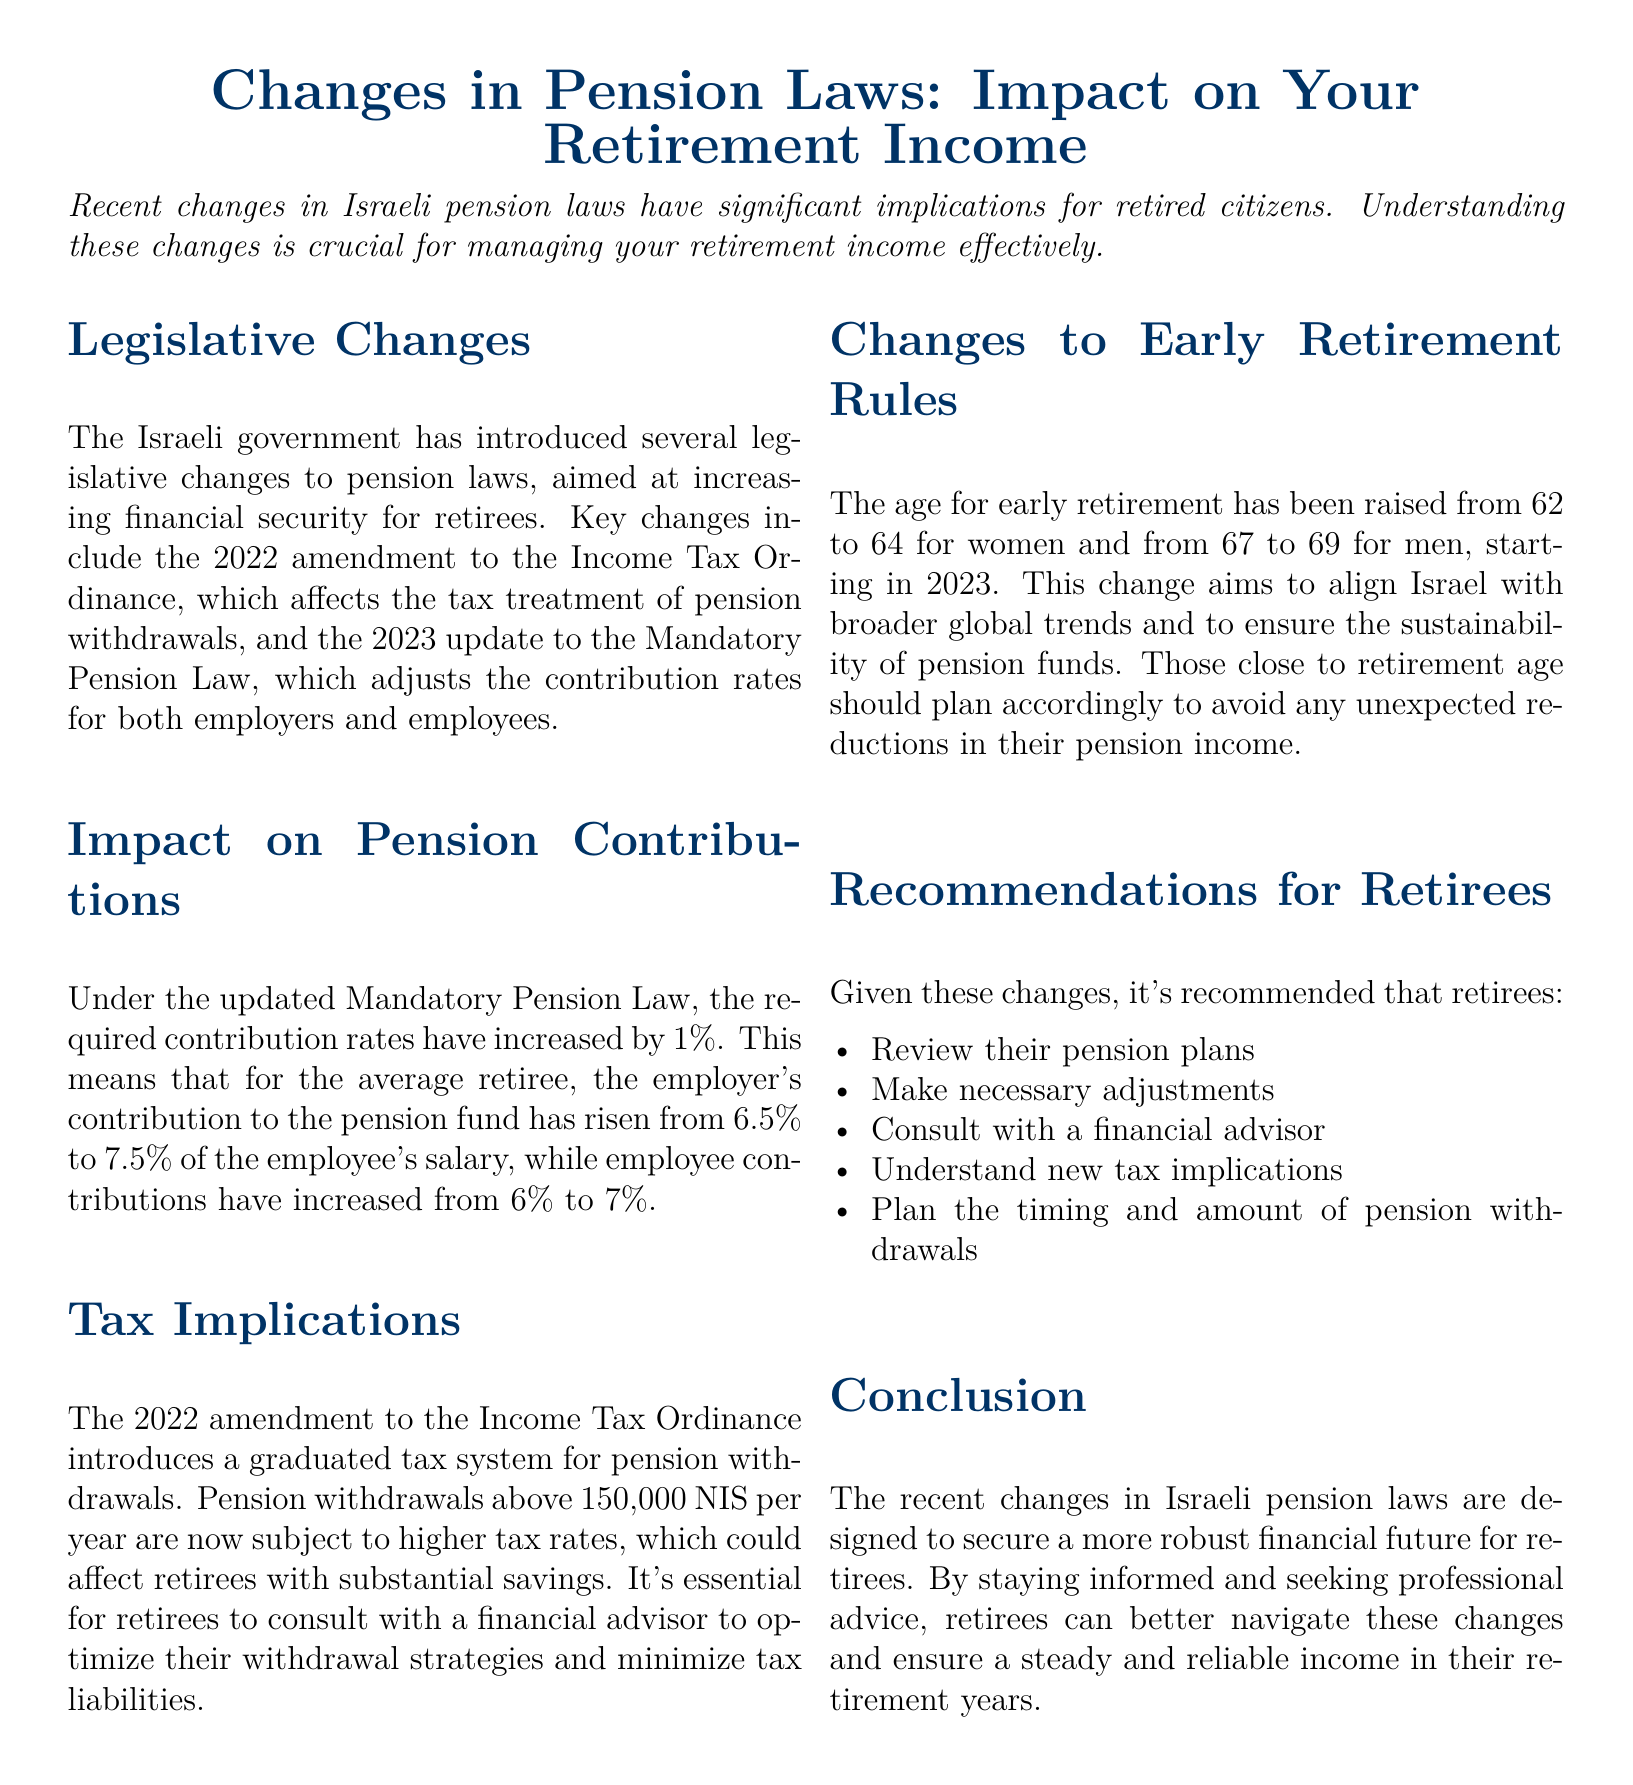What is the purpose of the recent changes in pension laws? The purpose is to increase financial security for retirees.
Answer: Increase financial security What is the increased contribution rate for employers under the new law? The employer's contribution rate has risen from 6.5% to 7.5%.
Answer: 7.5% What tax applies to pension withdrawals above 150,000 NIS? Withdrawals above this amount are subject to higher tax rates.
Answer: Higher tax rates What is the new early retirement age for women starting in 2023? The early retirement age for women has been raised to 64.
Answer: 64 What should retirees do to manage the new tax implications? Retirees should consult with a financial advisor.
Answer: Consult with a financial advisor How much have employee contributions increased under the updated Mandatory Pension Law? Employee contributions have increased from 6% to 7%.
Answer: 7% What financial strategy should retirees consider regarding pension withdrawals? Retirees should plan the timing and amount of withdrawals.
Answer: Plan the timing and amount What is the current retirement age for men following the changes? The retirement age for men has been raised to 69.
Answer: 69 In what year did the amendment to the Income Tax Ordinance take place? The amendment took place in 2022.
Answer: 2022 